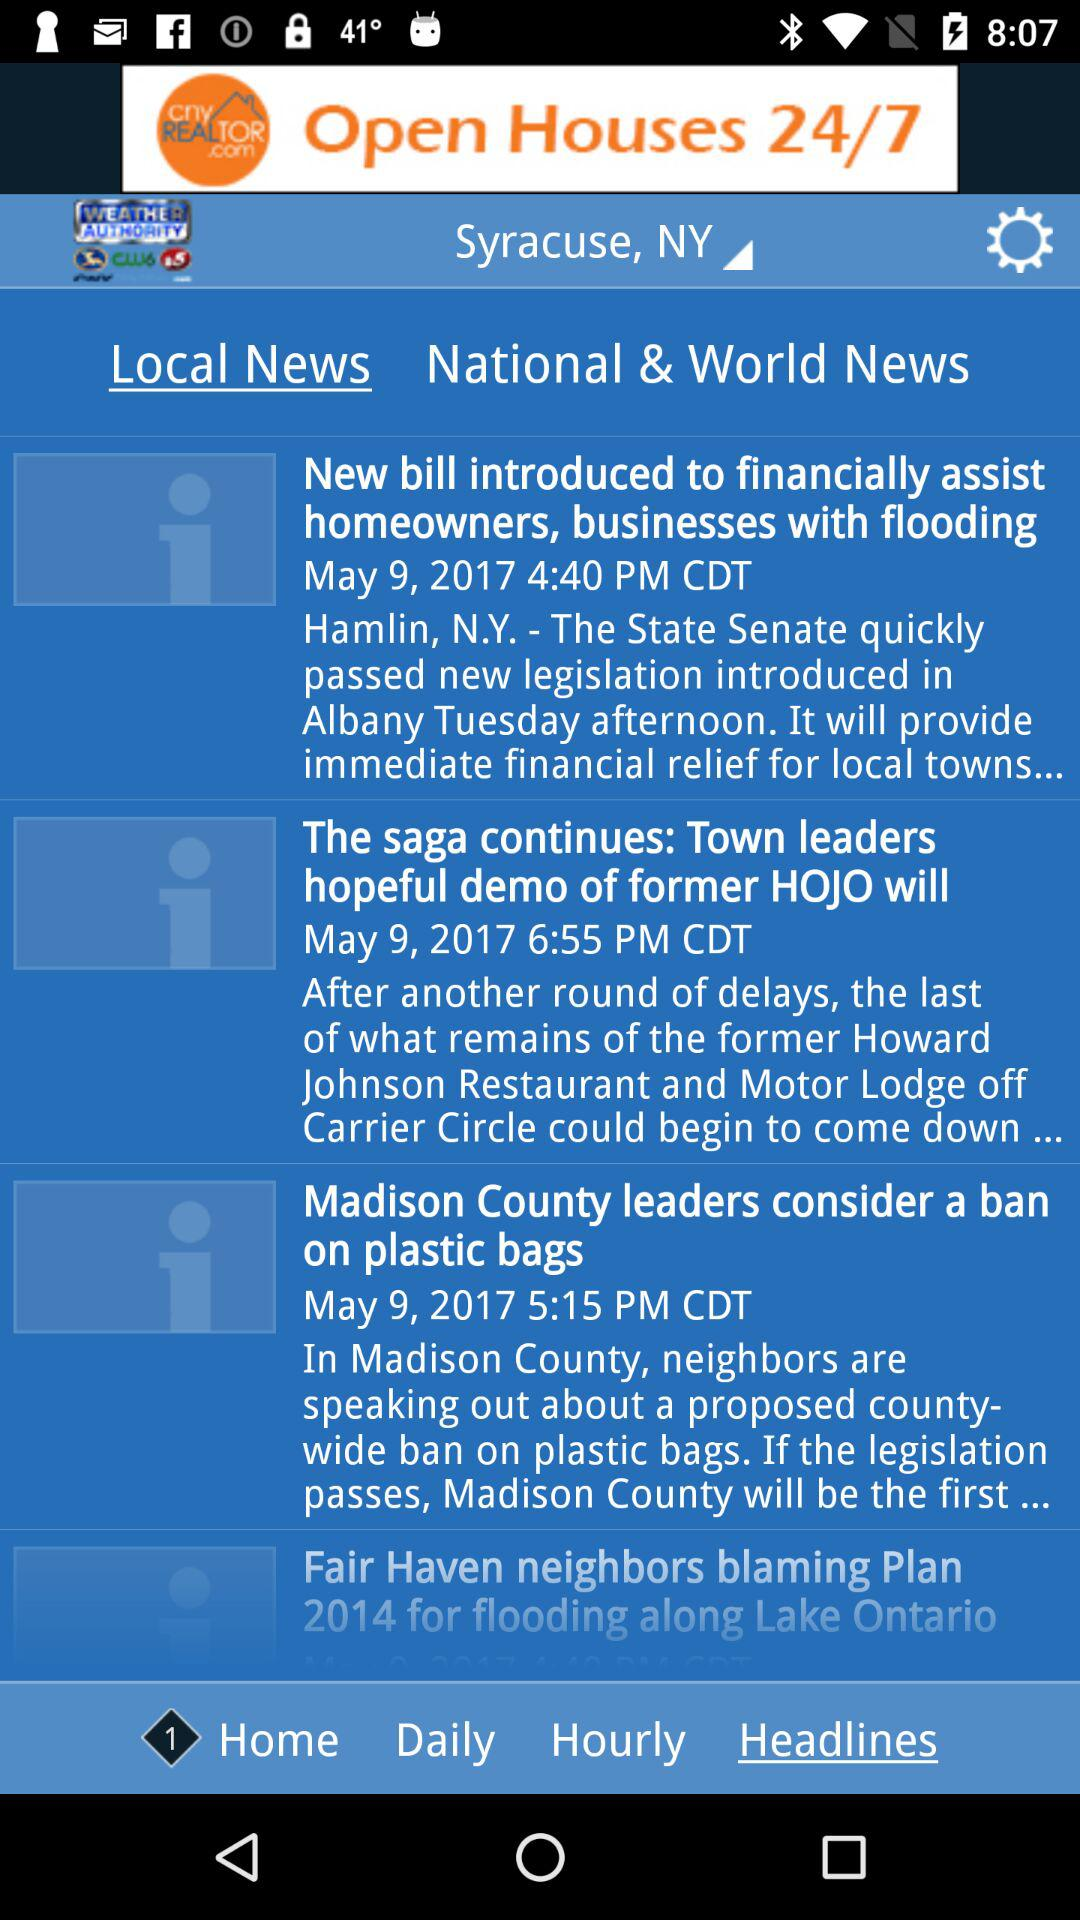How many news items are there on the screen?
Answer the question using a single word or phrase. 4 